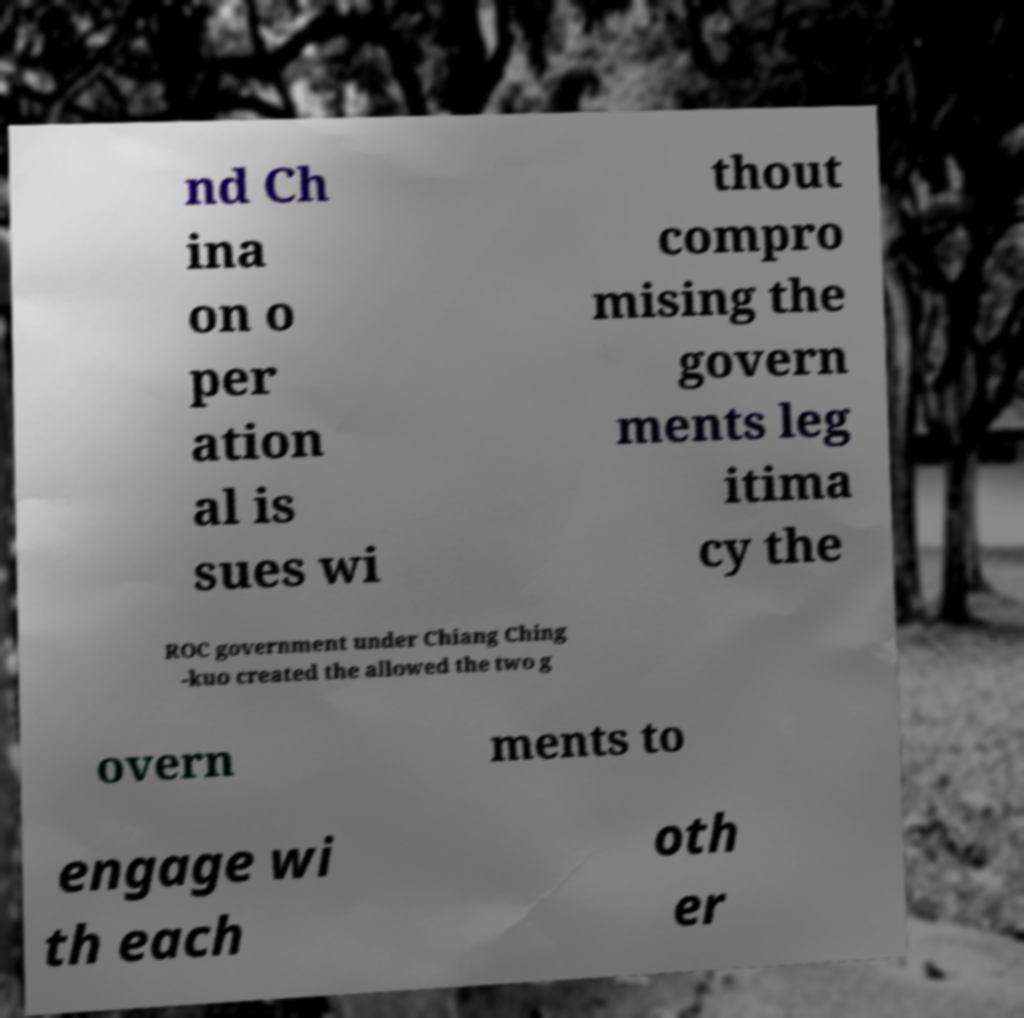I need the written content from this picture converted into text. Can you do that? nd Ch ina on o per ation al is sues wi thout compro mising the govern ments leg itima cy the ROC government under Chiang Ching -kuo created the allowed the two g overn ments to engage wi th each oth er 